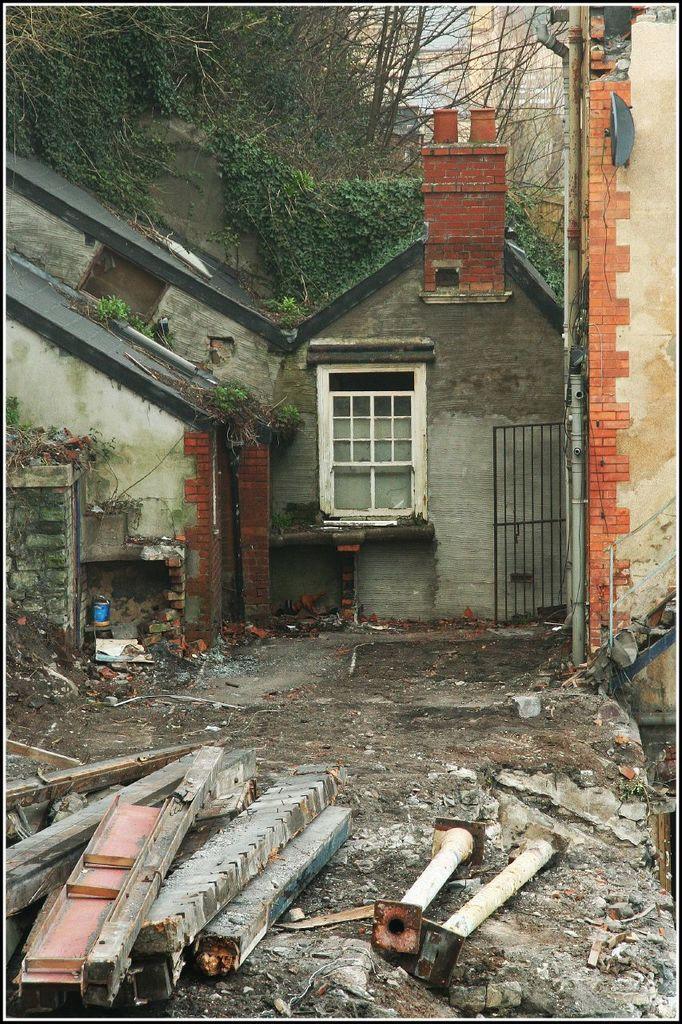In one or two sentences, can you explain what this image depicts? In the center of the image we can buildings with windows, roof. On the right side, we can see a gate, pipe and staircase. In the foreground we can see poles and wood logs placed on the ground. In the background, we can see a group of trees and the sky. 